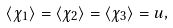Convert formula to latex. <formula><loc_0><loc_0><loc_500><loc_500>\langle \chi _ { 1 } \rangle = \langle \chi _ { 2 } \rangle = \langle \chi _ { 3 } \rangle = u ,</formula> 